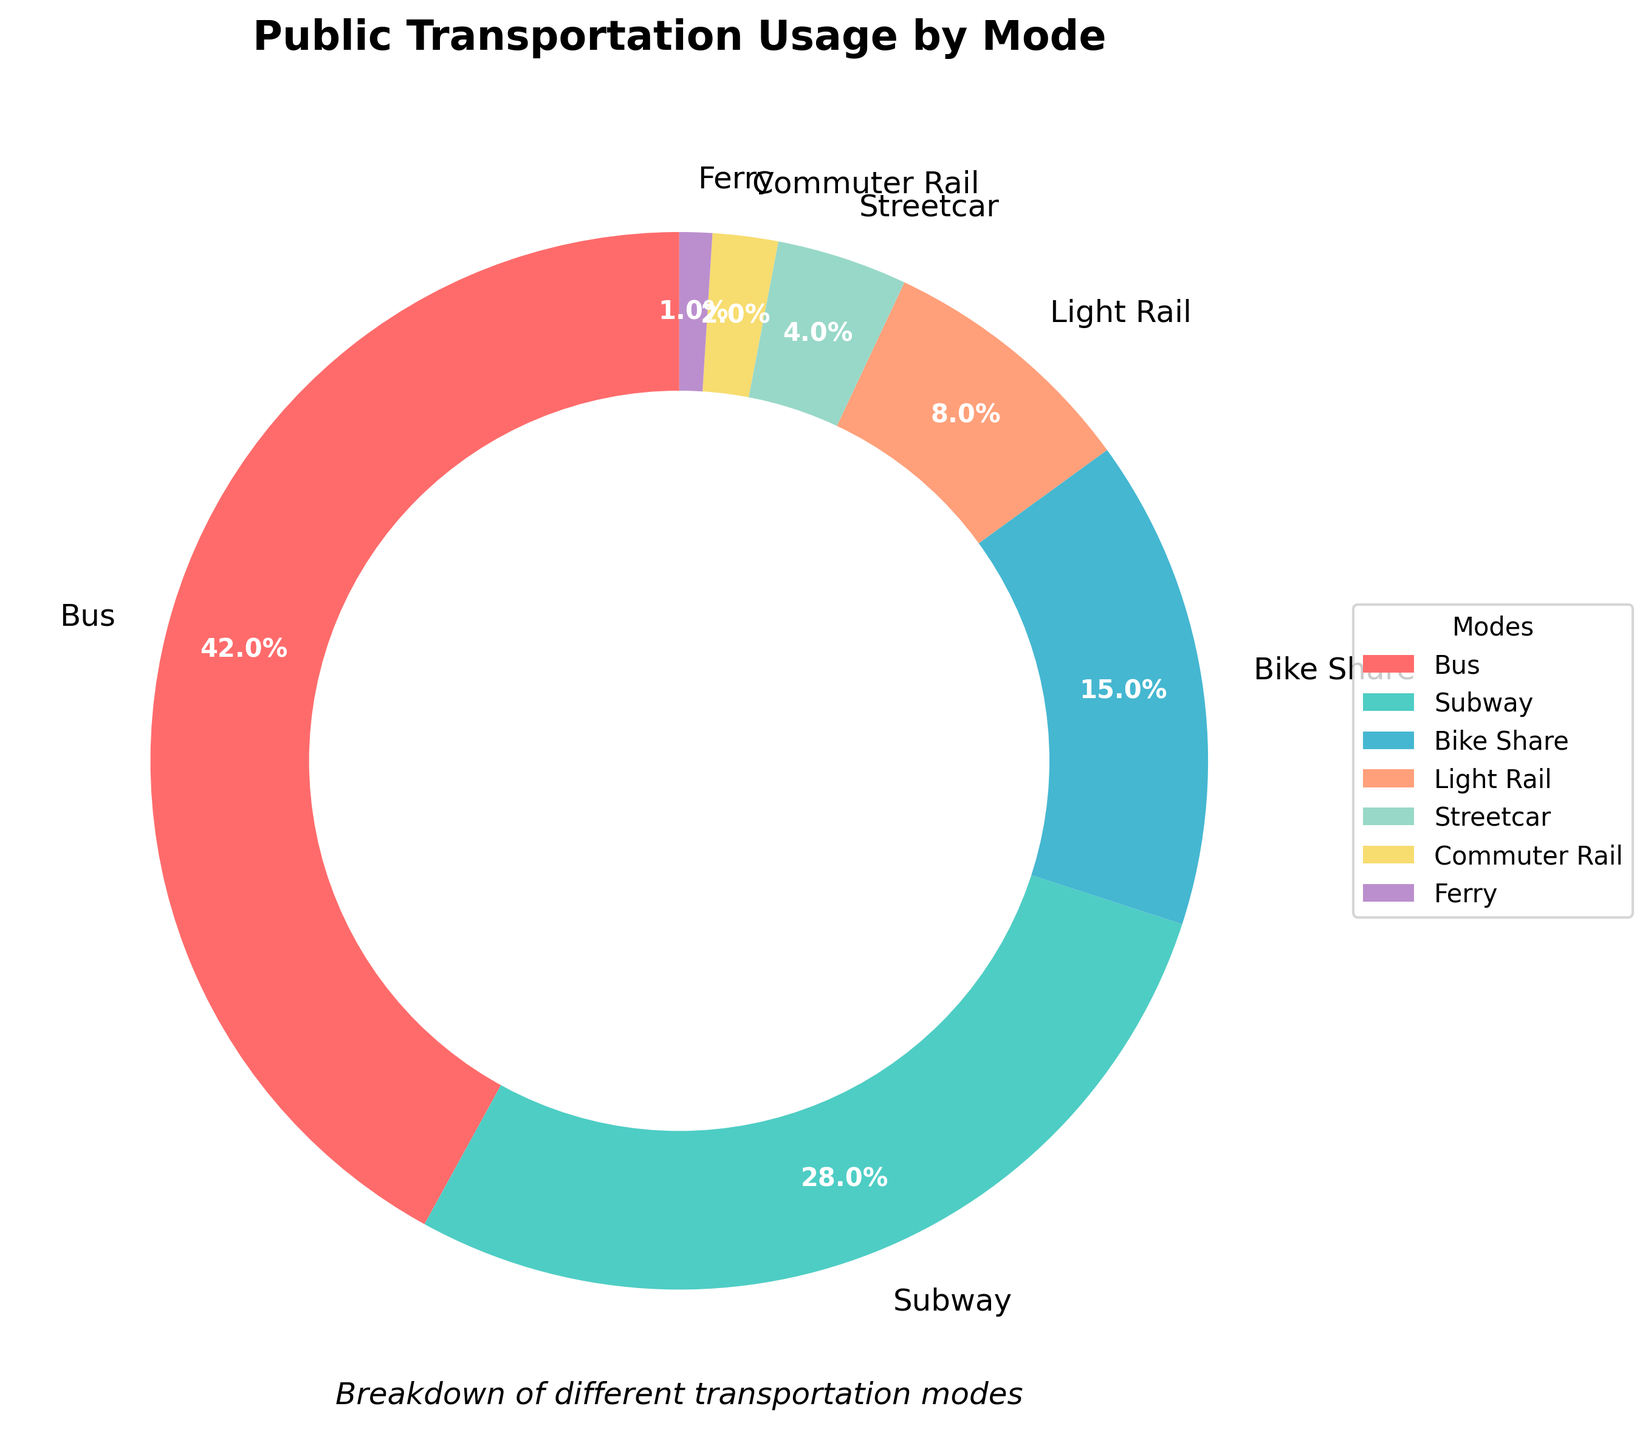Which mode of transportation is used the most? From the pie chart, the segment representing the bus has the largest size, thus indicating it has the highest usage percentage.
Answer: Bus What percentage of people use subway and bike share combined? The pie chart shows the usage of the subway is 28% and bike share is 15%. Add these percentages: 28% + 15% = 43%.
Answer: 43% Is bus usage greater than the combined usage of light rail, streetcar, commuter rail, and ferry? The bus usage is 42%. Combine the percentages of light rail (8%), streetcar (4%), commuter rail (2%), and ferry (1%): 8% + 4% + 2% + 1% = 15%. Since 42% > 15%, bus usage is indeed greater.
Answer: Yes Which transportation mode uses the pale purple color? By looking at the colors on the chart and the labels, pale purple is used for streetcar.
Answer: Streetcar Rank the transportation modes from most used to least used. Based on the pie chart, the ranking from most to least used is Bus (42%), Subway (28%), Bike Share (15%), Light Rail (8%), Streetcar (4%), Commuter Rail (2%), and Ferry (1%).
Answer: Bus, Subway, Bike Share, Light Rail, Streetcar, Commuter Rail, Ferry How much less is the percentage of people using the subway compared to the bus? The bus usage is 42% and subway usage is 28%. Subtract the subway percentage from the bus percentage: 42% - 28% = 14%.
Answer: 14% What is the average usage of light rail, streetcar, and commuter rail? The percentages are light rail (8%), streetcar (4%), and commuter rail (2%). Add the percentages and divide by 3: (8% + 4% + 2%) / 3 = 14% / 3 ≈ 4.67%.
Answer: ≈ 4.67% Which mode of transportation has the smallest usage, and what is that percentage? The pie chart shows that ferry has the smallest segment, indicating the smallest usage, which is 1%.
Answer: Ferry, 1% Is the usage of bike share greater than light rail and streetcar combined? The bike share percentage is 15%. Combine the percentages of light rail (8%) and streetcar (4%): 8% + 4% = 12%. Since 15% > 12%, bike share usage is greater.
Answer: Yes What transportation modes have usage percentages that total to 10% or less? From the chart, the modes with usage percentages of 10% or less are streetcar (4%), commuter rail (2%), and ferry (1%).
Answer: Streetcar, Commuter Rail, Ferry 